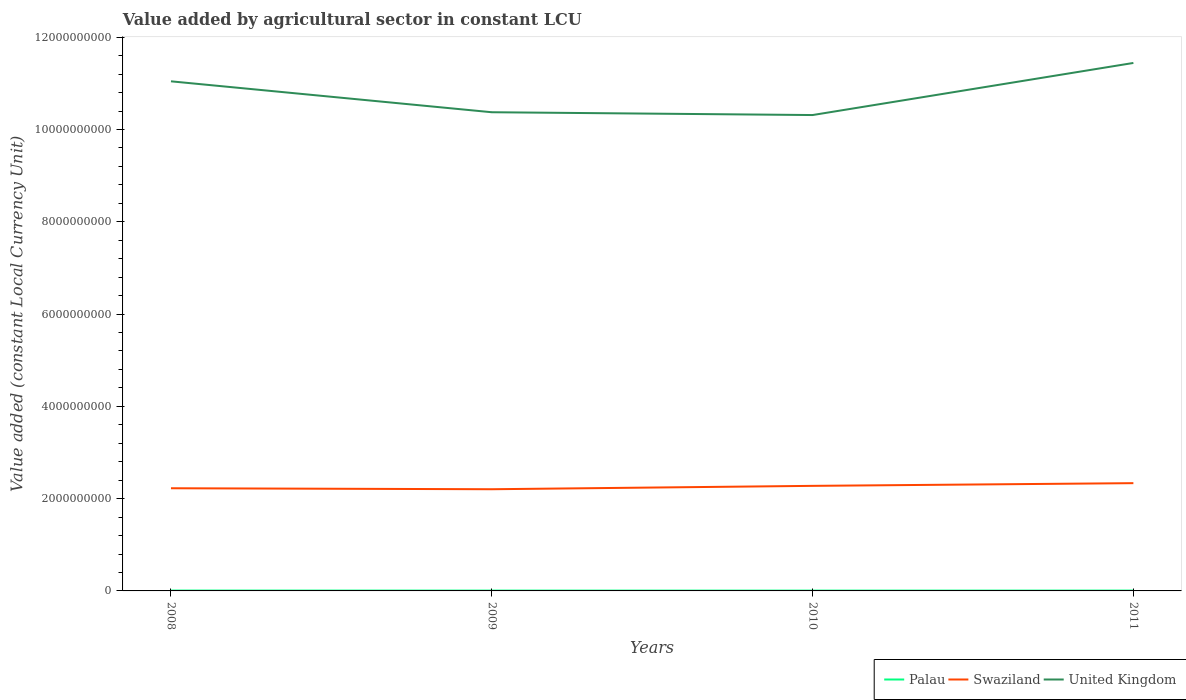Is the number of lines equal to the number of legend labels?
Keep it short and to the point. Yes. Across all years, what is the maximum value added by agricultural sector in Palau?
Provide a short and direct response. 6.64e+06. In which year was the value added by agricultural sector in United Kingdom maximum?
Your answer should be compact. 2010. What is the total value added by agricultural sector in United Kingdom in the graph?
Offer a very short reply. 6.70e+08. What is the difference between the highest and the second highest value added by agricultural sector in United Kingdom?
Offer a very short reply. 1.13e+09. How many years are there in the graph?
Offer a very short reply. 4. What is the difference between two consecutive major ticks on the Y-axis?
Offer a terse response. 2.00e+09. Are the values on the major ticks of Y-axis written in scientific E-notation?
Ensure brevity in your answer.  No. Does the graph contain any zero values?
Keep it short and to the point. No. Does the graph contain grids?
Make the answer very short. No. Where does the legend appear in the graph?
Ensure brevity in your answer.  Bottom right. What is the title of the graph?
Make the answer very short. Value added by agricultural sector in constant LCU. What is the label or title of the Y-axis?
Provide a short and direct response. Value added (constant Local Currency Unit). What is the Value added (constant Local Currency Unit) in Palau in 2008?
Offer a very short reply. 7.84e+06. What is the Value added (constant Local Currency Unit) in Swaziland in 2008?
Provide a succinct answer. 2.23e+09. What is the Value added (constant Local Currency Unit) in United Kingdom in 2008?
Your answer should be very brief. 1.10e+1. What is the Value added (constant Local Currency Unit) in Palau in 2009?
Provide a succinct answer. 7.00e+06. What is the Value added (constant Local Currency Unit) of Swaziland in 2009?
Your response must be concise. 2.20e+09. What is the Value added (constant Local Currency Unit) in United Kingdom in 2009?
Your answer should be very brief. 1.04e+1. What is the Value added (constant Local Currency Unit) of Palau in 2010?
Your response must be concise. 6.64e+06. What is the Value added (constant Local Currency Unit) in Swaziland in 2010?
Offer a terse response. 2.28e+09. What is the Value added (constant Local Currency Unit) in United Kingdom in 2010?
Give a very brief answer. 1.03e+1. What is the Value added (constant Local Currency Unit) in Palau in 2011?
Make the answer very short. 7.28e+06. What is the Value added (constant Local Currency Unit) of Swaziland in 2011?
Keep it short and to the point. 2.34e+09. What is the Value added (constant Local Currency Unit) in United Kingdom in 2011?
Make the answer very short. 1.14e+1. Across all years, what is the maximum Value added (constant Local Currency Unit) in Palau?
Provide a succinct answer. 7.84e+06. Across all years, what is the maximum Value added (constant Local Currency Unit) of Swaziland?
Your answer should be compact. 2.34e+09. Across all years, what is the maximum Value added (constant Local Currency Unit) in United Kingdom?
Your answer should be compact. 1.14e+1. Across all years, what is the minimum Value added (constant Local Currency Unit) of Palau?
Offer a very short reply. 6.64e+06. Across all years, what is the minimum Value added (constant Local Currency Unit) in Swaziland?
Offer a terse response. 2.20e+09. Across all years, what is the minimum Value added (constant Local Currency Unit) in United Kingdom?
Give a very brief answer. 1.03e+1. What is the total Value added (constant Local Currency Unit) in Palau in the graph?
Provide a short and direct response. 2.88e+07. What is the total Value added (constant Local Currency Unit) of Swaziland in the graph?
Provide a short and direct response. 9.04e+09. What is the total Value added (constant Local Currency Unit) of United Kingdom in the graph?
Ensure brevity in your answer.  4.32e+1. What is the difference between the Value added (constant Local Currency Unit) of Palau in 2008 and that in 2009?
Keep it short and to the point. 8.44e+05. What is the difference between the Value added (constant Local Currency Unit) in Swaziland in 2008 and that in 2009?
Your response must be concise. 2.11e+07. What is the difference between the Value added (constant Local Currency Unit) in United Kingdom in 2008 and that in 2009?
Offer a very short reply. 6.70e+08. What is the difference between the Value added (constant Local Currency Unit) in Palau in 2008 and that in 2010?
Ensure brevity in your answer.  1.20e+06. What is the difference between the Value added (constant Local Currency Unit) of Swaziland in 2008 and that in 2010?
Your answer should be very brief. -5.18e+07. What is the difference between the Value added (constant Local Currency Unit) in United Kingdom in 2008 and that in 2010?
Offer a very short reply. 7.31e+08. What is the difference between the Value added (constant Local Currency Unit) of Palau in 2008 and that in 2011?
Your response must be concise. 5.64e+05. What is the difference between the Value added (constant Local Currency Unit) of Swaziland in 2008 and that in 2011?
Give a very brief answer. -1.10e+08. What is the difference between the Value added (constant Local Currency Unit) of United Kingdom in 2008 and that in 2011?
Your answer should be compact. -3.98e+08. What is the difference between the Value added (constant Local Currency Unit) of Palau in 2009 and that in 2010?
Make the answer very short. 3.53e+05. What is the difference between the Value added (constant Local Currency Unit) in Swaziland in 2009 and that in 2010?
Make the answer very short. -7.29e+07. What is the difference between the Value added (constant Local Currency Unit) in United Kingdom in 2009 and that in 2010?
Offer a very short reply. 6.07e+07. What is the difference between the Value added (constant Local Currency Unit) in Palau in 2009 and that in 2011?
Give a very brief answer. -2.80e+05. What is the difference between the Value added (constant Local Currency Unit) in Swaziland in 2009 and that in 2011?
Your response must be concise. -1.31e+08. What is the difference between the Value added (constant Local Currency Unit) in United Kingdom in 2009 and that in 2011?
Provide a succinct answer. -1.07e+09. What is the difference between the Value added (constant Local Currency Unit) of Palau in 2010 and that in 2011?
Offer a terse response. -6.32e+05. What is the difference between the Value added (constant Local Currency Unit) of Swaziland in 2010 and that in 2011?
Your response must be concise. -5.85e+07. What is the difference between the Value added (constant Local Currency Unit) of United Kingdom in 2010 and that in 2011?
Offer a very short reply. -1.13e+09. What is the difference between the Value added (constant Local Currency Unit) of Palau in 2008 and the Value added (constant Local Currency Unit) of Swaziland in 2009?
Give a very brief answer. -2.20e+09. What is the difference between the Value added (constant Local Currency Unit) in Palau in 2008 and the Value added (constant Local Currency Unit) in United Kingdom in 2009?
Keep it short and to the point. -1.04e+1. What is the difference between the Value added (constant Local Currency Unit) in Swaziland in 2008 and the Value added (constant Local Currency Unit) in United Kingdom in 2009?
Make the answer very short. -8.15e+09. What is the difference between the Value added (constant Local Currency Unit) in Palau in 2008 and the Value added (constant Local Currency Unit) in Swaziland in 2010?
Keep it short and to the point. -2.27e+09. What is the difference between the Value added (constant Local Currency Unit) of Palau in 2008 and the Value added (constant Local Currency Unit) of United Kingdom in 2010?
Keep it short and to the point. -1.03e+1. What is the difference between the Value added (constant Local Currency Unit) in Swaziland in 2008 and the Value added (constant Local Currency Unit) in United Kingdom in 2010?
Give a very brief answer. -8.09e+09. What is the difference between the Value added (constant Local Currency Unit) in Palau in 2008 and the Value added (constant Local Currency Unit) in Swaziland in 2011?
Give a very brief answer. -2.33e+09. What is the difference between the Value added (constant Local Currency Unit) in Palau in 2008 and the Value added (constant Local Currency Unit) in United Kingdom in 2011?
Make the answer very short. -1.14e+1. What is the difference between the Value added (constant Local Currency Unit) of Swaziland in 2008 and the Value added (constant Local Currency Unit) of United Kingdom in 2011?
Offer a terse response. -9.22e+09. What is the difference between the Value added (constant Local Currency Unit) of Palau in 2009 and the Value added (constant Local Currency Unit) of Swaziland in 2010?
Give a very brief answer. -2.27e+09. What is the difference between the Value added (constant Local Currency Unit) in Palau in 2009 and the Value added (constant Local Currency Unit) in United Kingdom in 2010?
Provide a succinct answer. -1.03e+1. What is the difference between the Value added (constant Local Currency Unit) of Swaziland in 2009 and the Value added (constant Local Currency Unit) of United Kingdom in 2010?
Offer a terse response. -8.11e+09. What is the difference between the Value added (constant Local Currency Unit) of Palau in 2009 and the Value added (constant Local Currency Unit) of Swaziland in 2011?
Your answer should be very brief. -2.33e+09. What is the difference between the Value added (constant Local Currency Unit) in Palau in 2009 and the Value added (constant Local Currency Unit) in United Kingdom in 2011?
Make the answer very short. -1.14e+1. What is the difference between the Value added (constant Local Currency Unit) in Swaziland in 2009 and the Value added (constant Local Currency Unit) in United Kingdom in 2011?
Give a very brief answer. -9.24e+09. What is the difference between the Value added (constant Local Currency Unit) of Palau in 2010 and the Value added (constant Local Currency Unit) of Swaziland in 2011?
Provide a short and direct response. -2.33e+09. What is the difference between the Value added (constant Local Currency Unit) in Palau in 2010 and the Value added (constant Local Currency Unit) in United Kingdom in 2011?
Offer a terse response. -1.14e+1. What is the difference between the Value added (constant Local Currency Unit) of Swaziland in 2010 and the Value added (constant Local Currency Unit) of United Kingdom in 2011?
Keep it short and to the point. -9.17e+09. What is the average Value added (constant Local Currency Unit) in Palau per year?
Your answer should be compact. 7.19e+06. What is the average Value added (constant Local Currency Unit) of Swaziland per year?
Provide a short and direct response. 2.26e+09. What is the average Value added (constant Local Currency Unit) in United Kingdom per year?
Provide a short and direct response. 1.08e+1. In the year 2008, what is the difference between the Value added (constant Local Currency Unit) of Palau and Value added (constant Local Currency Unit) of Swaziland?
Offer a very short reply. -2.22e+09. In the year 2008, what is the difference between the Value added (constant Local Currency Unit) of Palau and Value added (constant Local Currency Unit) of United Kingdom?
Provide a short and direct response. -1.10e+1. In the year 2008, what is the difference between the Value added (constant Local Currency Unit) in Swaziland and Value added (constant Local Currency Unit) in United Kingdom?
Provide a succinct answer. -8.82e+09. In the year 2009, what is the difference between the Value added (constant Local Currency Unit) of Palau and Value added (constant Local Currency Unit) of Swaziland?
Make the answer very short. -2.20e+09. In the year 2009, what is the difference between the Value added (constant Local Currency Unit) in Palau and Value added (constant Local Currency Unit) in United Kingdom?
Give a very brief answer. -1.04e+1. In the year 2009, what is the difference between the Value added (constant Local Currency Unit) of Swaziland and Value added (constant Local Currency Unit) of United Kingdom?
Your response must be concise. -8.17e+09. In the year 2010, what is the difference between the Value added (constant Local Currency Unit) in Palau and Value added (constant Local Currency Unit) in Swaziland?
Offer a very short reply. -2.27e+09. In the year 2010, what is the difference between the Value added (constant Local Currency Unit) of Palau and Value added (constant Local Currency Unit) of United Kingdom?
Ensure brevity in your answer.  -1.03e+1. In the year 2010, what is the difference between the Value added (constant Local Currency Unit) in Swaziland and Value added (constant Local Currency Unit) in United Kingdom?
Ensure brevity in your answer.  -8.04e+09. In the year 2011, what is the difference between the Value added (constant Local Currency Unit) of Palau and Value added (constant Local Currency Unit) of Swaziland?
Provide a succinct answer. -2.33e+09. In the year 2011, what is the difference between the Value added (constant Local Currency Unit) in Palau and Value added (constant Local Currency Unit) in United Kingdom?
Provide a short and direct response. -1.14e+1. In the year 2011, what is the difference between the Value added (constant Local Currency Unit) in Swaziland and Value added (constant Local Currency Unit) in United Kingdom?
Give a very brief answer. -9.11e+09. What is the ratio of the Value added (constant Local Currency Unit) of Palau in 2008 to that in 2009?
Give a very brief answer. 1.12. What is the ratio of the Value added (constant Local Currency Unit) in Swaziland in 2008 to that in 2009?
Keep it short and to the point. 1.01. What is the ratio of the Value added (constant Local Currency Unit) of United Kingdom in 2008 to that in 2009?
Your answer should be very brief. 1.06. What is the ratio of the Value added (constant Local Currency Unit) in Palau in 2008 to that in 2010?
Your answer should be very brief. 1.18. What is the ratio of the Value added (constant Local Currency Unit) in Swaziland in 2008 to that in 2010?
Your answer should be compact. 0.98. What is the ratio of the Value added (constant Local Currency Unit) of United Kingdom in 2008 to that in 2010?
Ensure brevity in your answer.  1.07. What is the ratio of the Value added (constant Local Currency Unit) of Palau in 2008 to that in 2011?
Offer a very short reply. 1.08. What is the ratio of the Value added (constant Local Currency Unit) in Swaziland in 2008 to that in 2011?
Make the answer very short. 0.95. What is the ratio of the Value added (constant Local Currency Unit) of United Kingdom in 2008 to that in 2011?
Ensure brevity in your answer.  0.97. What is the ratio of the Value added (constant Local Currency Unit) in Palau in 2009 to that in 2010?
Provide a succinct answer. 1.05. What is the ratio of the Value added (constant Local Currency Unit) of Swaziland in 2009 to that in 2010?
Your response must be concise. 0.97. What is the ratio of the Value added (constant Local Currency Unit) of United Kingdom in 2009 to that in 2010?
Your answer should be compact. 1.01. What is the ratio of the Value added (constant Local Currency Unit) of Palau in 2009 to that in 2011?
Give a very brief answer. 0.96. What is the ratio of the Value added (constant Local Currency Unit) of Swaziland in 2009 to that in 2011?
Ensure brevity in your answer.  0.94. What is the ratio of the Value added (constant Local Currency Unit) in United Kingdom in 2009 to that in 2011?
Your response must be concise. 0.91. What is the ratio of the Value added (constant Local Currency Unit) in Palau in 2010 to that in 2011?
Ensure brevity in your answer.  0.91. What is the ratio of the Value added (constant Local Currency Unit) in Swaziland in 2010 to that in 2011?
Offer a very short reply. 0.97. What is the ratio of the Value added (constant Local Currency Unit) of United Kingdom in 2010 to that in 2011?
Keep it short and to the point. 0.9. What is the difference between the highest and the second highest Value added (constant Local Currency Unit) of Palau?
Provide a succinct answer. 5.64e+05. What is the difference between the highest and the second highest Value added (constant Local Currency Unit) of Swaziland?
Make the answer very short. 5.85e+07. What is the difference between the highest and the second highest Value added (constant Local Currency Unit) of United Kingdom?
Offer a terse response. 3.98e+08. What is the difference between the highest and the lowest Value added (constant Local Currency Unit) in Palau?
Offer a very short reply. 1.20e+06. What is the difference between the highest and the lowest Value added (constant Local Currency Unit) in Swaziland?
Your answer should be compact. 1.31e+08. What is the difference between the highest and the lowest Value added (constant Local Currency Unit) in United Kingdom?
Keep it short and to the point. 1.13e+09. 